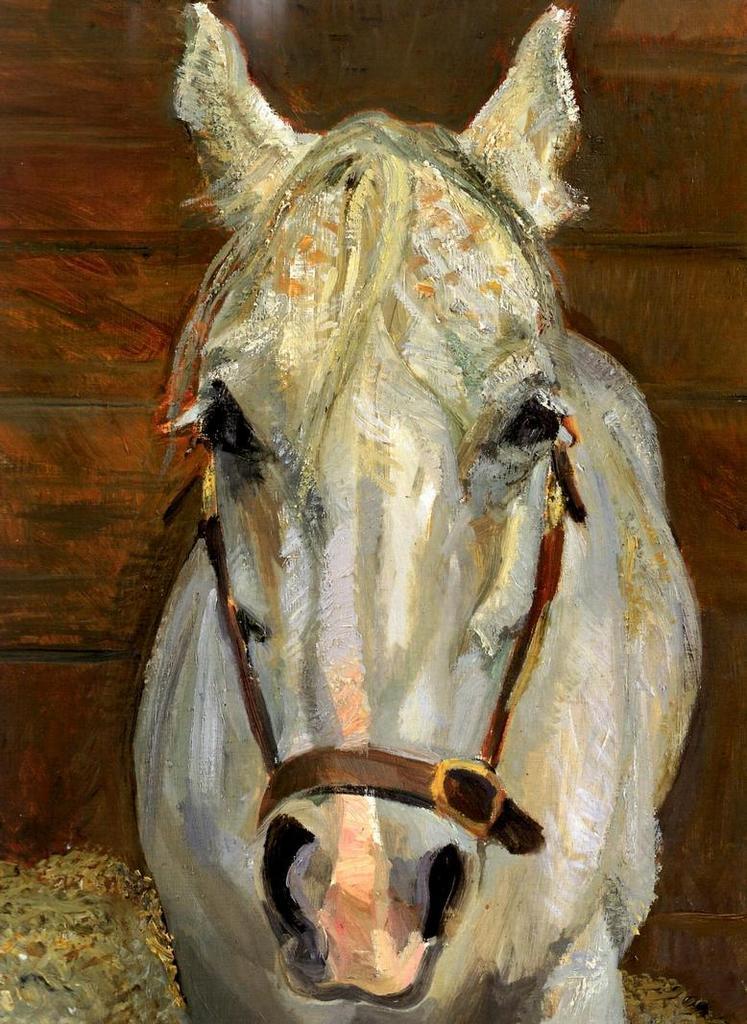In one or two sentences, can you explain what this image depicts? In the picture we can see a painting of the horse from the front which is white in color and tied with the belts and in the background we can see a wooden wall. 